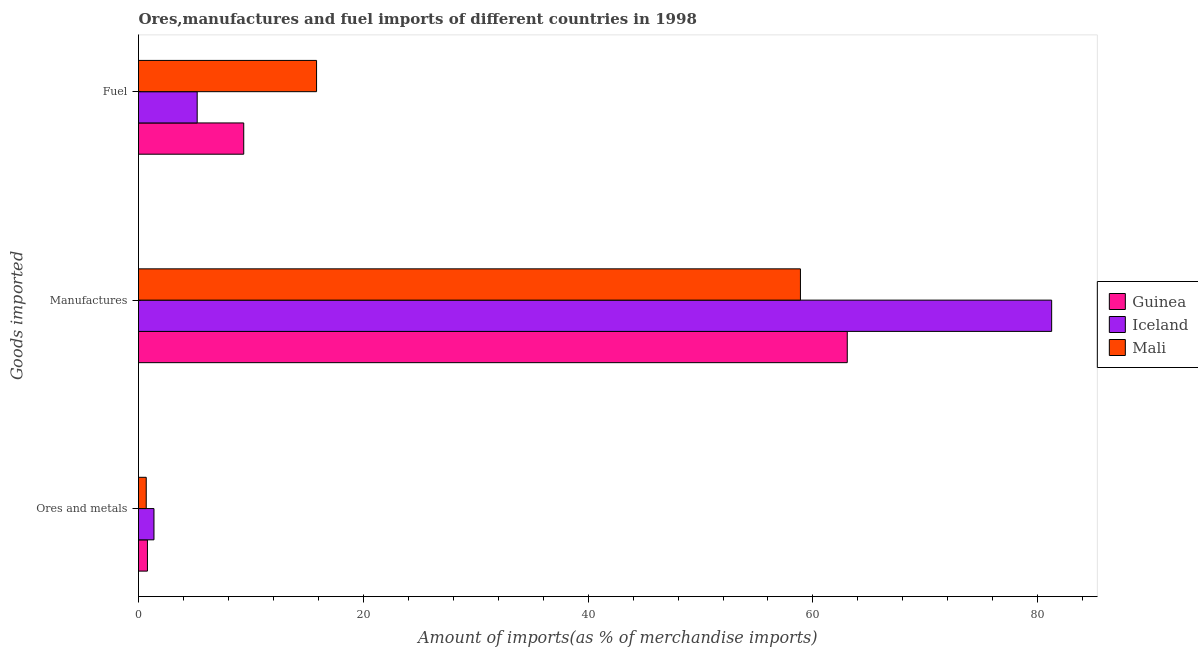Are the number of bars on each tick of the Y-axis equal?
Your answer should be compact. Yes. How many bars are there on the 3rd tick from the top?
Provide a short and direct response. 3. What is the label of the 1st group of bars from the top?
Ensure brevity in your answer.  Fuel. What is the percentage of ores and metals imports in Guinea?
Ensure brevity in your answer.  0.79. Across all countries, what is the maximum percentage of ores and metals imports?
Your answer should be very brief. 1.38. Across all countries, what is the minimum percentage of manufactures imports?
Your answer should be compact. 58.89. In which country was the percentage of manufactures imports maximum?
Your answer should be compact. Iceland. In which country was the percentage of fuel imports minimum?
Provide a short and direct response. Iceland. What is the total percentage of manufactures imports in the graph?
Offer a very short reply. 203.18. What is the difference between the percentage of manufactures imports in Iceland and that in Mali?
Keep it short and to the point. 22.35. What is the difference between the percentage of manufactures imports in Mali and the percentage of ores and metals imports in Guinea?
Keep it short and to the point. 58.09. What is the average percentage of fuel imports per country?
Provide a succinct answer. 10.14. What is the difference between the percentage of fuel imports and percentage of manufactures imports in Iceland?
Make the answer very short. -76.02. What is the ratio of the percentage of fuel imports in Iceland to that in Mali?
Your answer should be compact. 0.33. Is the percentage of fuel imports in Mali less than that in Guinea?
Offer a terse response. No. What is the difference between the highest and the second highest percentage of ores and metals imports?
Your answer should be compact. 0.58. What is the difference between the highest and the lowest percentage of manufactures imports?
Offer a very short reply. 22.35. What does the 1st bar from the bottom in Manufactures represents?
Keep it short and to the point. Guinea. Is it the case that in every country, the sum of the percentage of ores and metals imports and percentage of manufactures imports is greater than the percentage of fuel imports?
Your response must be concise. Yes. Are all the bars in the graph horizontal?
Provide a short and direct response. Yes. How many countries are there in the graph?
Keep it short and to the point. 3. Are the values on the major ticks of X-axis written in scientific E-notation?
Your response must be concise. No. Where does the legend appear in the graph?
Your answer should be compact. Center right. What is the title of the graph?
Keep it short and to the point. Ores,manufactures and fuel imports of different countries in 1998. What is the label or title of the X-axis?
Your response must be concise. Amount of imports(as % of merchandise imports). What is the label or title of the Y-axis?
Keep it short and to the point. Goods imported. What is the Amount of imports(as % of merchandise imports) of Guinea in Ores and metals?
Make the answer very short. 0.79. What is the Amount of imports(as % of merchandise imports) of Iceland in Ores and metals?
Give a very brief answer. 1.38. What is the Amount of imports(as % of merchandise imports) in Mali in Ores and metals?
Your answer should be compact. 0.69. What is the Amount of imports(as % of merchandise imports) in Guinea in Manufactures?
Your answer should be compact. 63.05. What is the Amount of imports(as % of merchandise imports) in Iceland in Manufactures?
Your answer should be very brief. 81.24. What is the Amount of imports(as % of merchandise imports) in Mali in Manufactures?
Offer a terse response. 58.89. What is the Amount of imports(as % of merchandise imports) of Guinea in Fuel?
Make the answer very short. 9.36. What is the Amount of imports(as % of merchandise imports) of Iceland in Fuel?
Provide a short and direct response. 5.22. What is the Amount of imports(as % of merchandise imports) of Mali in Fuel?
Your answer should be very brief. 15.84. Across all Goods imported, what is the maximum Amount of imports(as % of merchandise imports) of Guinea?
Provide a succinct answer. 63.05. Across all Goods imported, what is the maximum Amount of imports(as % of merchandise imports) in Iceland?
Make the answer very short. 81.24. Across all Goods imported, what is the maximum Amount of imports(as % of merchandise imports) of Mali?
Keep it short and to the point. 58.89. Across all Goods imported, what is the minimum Amount of imports(as % of merchandise imports) in Guinea?
Provide a succinct answer. 0.79. Across all Goods imported, what is the minimum Amount of imports(as % of merchandise imports) in Iceland?
Your answer should be compact. 1.38. Across all Goods imported, what is the minimum Amount of imports(as % of merchandise imports) of Mali?
Keep it short and to the point. 0.69. What is the total Amount of imports(as % of merchandise imports) in Guinea in the graph?
Offer a terse response. 73.21. What is the total Amount of imports(as % of merchandise imports) of Iceland in the graph?
Your answer should be very brief. 87.83. What is the total Amount of imports(as % of merchandise imports) of Mali in the graph?
Your answer should be compact. 75.42. What is the difference between the Amount of imports(as % of merchandise imports) of Guinea in Ores and metals and that in Manufactures?
Provide a succinct answer. -62.26. What is the difference between the Amount of imports(as % of merchandise imports) of Iceland in Ores and metals and that in Manufactures?
Your response must be concise. -79.86. What is the difference between the Amount of imports(as % of merchandise imports) in Mali in Ores and metals and that in Manufactures?
Your answer should be very brief. -58.2. What is the difference between the Amount of imports(as % of merchandise imports) in Guinea in Ores and metals and that in Fuel?
Your response must be concise. -8.57. What is the difference between the Amount of imports(as % of merchandise imports) in Iceland in Ores and metals and that in Fuel?
Your response must be concise. -3.85. What is the difference between the Amount of imports(as % of merchandise imports) in Mali in Ores and metals and that in Fuel?
Your answer should be compact. -15.15. What is the difference between the Amount of imports(as % of merchandise imports) of Guinea in Manufactures and that in Fuel?
Keep it short and to the point. 53.69. What is the difference between the Amount of imports(as % of merchandise imports) of Iceland in Manufactures and that in Fuel?
Provide a short and direct response. 76.02. What is the difference between the Amount of imports(as % of merchandise imports) of Mali in Manufactures and that in Fuel?
Offer a very short reply. 43.05. What is the difference between the Amount of imports(as % of merchandise imports) in Guinea in Ores and metals and the Amount of imports(as % of merchandise imports) in Iceland in Manufactures?
Offer a very short reply. -80.44. What is the difference between the Amount of imports(as % of merchandise imports) of Guinea in Ores and metals and the Amount of imports(as % of merchandise imports) of Mali in Manufactures?
Your answer should be compact. -58.09. What is the difference between the Amount of imports(as % of merchandise imports) in Iceland in Ores and metals and the Amount of imports(as % of merchandise imports) in Mali in Manufactures?
Offer a terse response. -57.51. What is the difference between the Amount of imports(as % of merchandise imports) in Guinea in Ores and metals and the Amount of imports(as % of merchandise imports) in Iceland in Fuel?
Provide a succinct answer. -4.43. What is the difference between the Amount of imports(as % of merchandise imports) in Guinea in Ores and metals and the Amount of imports(as % of merchandise imports) in Mali in Fuel?
Keep it short and to the point. -15.05. What is the difference between the Amount of imports(as % of merchandise imports) in Iceland in Ores and metals and the Amount of imports(as % of merchandise imports) in Mali in Fuel?
Provide a short and direct response. -14.47. What is the difference between the Amount of imports(as % of merchandise imports) in Guinea in Manufactures and the Amount of imports(as % of merchandise imports) in Iceland in Fuel?
Provide a short and direct response. 57.83. What is the difference between the Amount of imports(as % of merchandise imports) of Guinea in Manufactures and the Amount of imports(as % of merchandise imports) of Mali in Fuel?
Your answer should be compact. 47.21. What is the difference between the Amount of imports(as % of merchandise imports) of Iceland in Manufactures and the Amount of imports(as % of merchandise imports) of Mali in Fuel?
Your answer should be compact. 65.4. What is the average Amount of imports(as % of merchandise imports) in Guinea per Goods imported?
Make the answer very short. 24.4. What is the average Amount of imports(as % of merchandise imports) in Iceland per Goods imported?
Your answer should be very brief. 29.28. What is the average Amount of imports(as % of merchandise imports) of Mali per Goods imported?
Offer a terse response. 25.14. What is the difference between the Amount of imports(as % of merchandise imports) of Guinea and Amount of imports(as % of merchandise imports) of Iceland in Ores and metals?
Give a very brief answer. -0.58. What is the difference between the Amount of imports(as % of merchandise imports) of Guinea and Amount of imports(as % of merchandise imports) of Mali in Ores and metals?
Your answer should be very brief. 0.11. What is the difference between the Amount of imports(as % of merchandise imports) of Iceland and Amount of imports(as % of merchandise imports) of Mali in Ores and metals?
Ensure brevity in your answer.  0.69. What is the difference between the Amount of imports(as % of merchandise imports) in Guinea and Amount of imports(as % of merchandise imports) in Iceland in Manufactures?
Offer a very short reply. -18.18. What is the difference between the Amount of imports(as % of merchandise imports) in Guinea and Amount of imports(as % of merchandise imports) in Mali in Manufactures?
Keep it short and to the point. 4.17. What is the difference between the Amount of imports(as % of merchandise imports) in Iceland and Amount of imports(as % of merchandise imports) in Mali in Manufactures?
Give a very brief answer. 22.35. What is the difference between the Amount of imports(as % of merchandise imports) of Guinea and Amount of imports(as % of merchandise imports) of Iceland in Fuel?
Keep it short and to the point. 4.14. What is the difference between the Amount of imports(as % of merchandise imports) of Guinea and Amount of imports(as % of merchandise imports) of Mali in Fuel?
Your answer should be compact. -6.48. What is the difference between the Amount of imports(as % of merchandise imports) in Iceland and Amount of imports(as % of merchandise imports) in Mali in Fuel?
Offer a very short reply. -10.62. What is the ratio of the Amount of imports(as % of merchandise imports) of Guinea in Ores and metals to that in Manufactures?
Ensure brevity in your answer.  0.01. What is the ratio of the Amount of imports(as % of merchandise imports) in Iceland in Ores and metals to that in Manufactures?
Make the answer very short. 0.02. What is the ratio of the Amount of imports(as % of merchandise imports) in Mali in Ores and metals to that in Manufactures?
Your response must be concise. 0.01. What is the ratio of the Amount of imports(as % of merchandise imports) in Guinea in Ores and metals to that in Fuel?
Keep it short and to the point. 0.08. What is the ratio of the Amount of imports(as % of merchandise imports) in Iceland in Ores and metals to that in Fuel?
Give a very brief answer. 0.26. What is the ratio of the Amount of imports(as % of merchandise imports) in Mali in Ores and metals to that in Fuel?
Provide a short and direct response. 0.04. What is the ratio of the Amount of imports(as % of merchandise imports) of Guinea in Manufactures to that in Fuel?
Your answer should be compact. 6.74. What is the ratio of the Amount of imports(as % of merchandise imports) of Iceland in Manufactures to that in Fuel?
Your answer should be very brief. 15.56. What is the ratio of the Amount of imports(as % of merchandise imports) in Mali in Manufactures to that in Fuel?
Your answer should be compact. 3.72. What is the difference between the highest and the second highest Amount of imports(as % of merchandise imports) of Guinea?
Your answer should be very brief. 53.69. What is the difference between the highest and the second highest Amount of imports(as % of merchandise imports) of Iceland?
Your answer should be very brief. 76.02. What is the difference between the highest and the second highest Amount of imports(as % of merchandise imports) in Mali?
Your answer should be very brief. 43.05. What is the difference between the highest and the lowest Amount of imports(as % of merchandise imports) of Guinea?
Make the answer very short. 62.26. What is the difference between the highest and the lowest Amount of imports(as % of merchandise imports) in Iceland?
Keep it short and to the point. 79.86. What is the difference between the highest and the lowest Amount of imports(as % of merchandise imports) of Mali?
Offer a terse response. 58.2. 